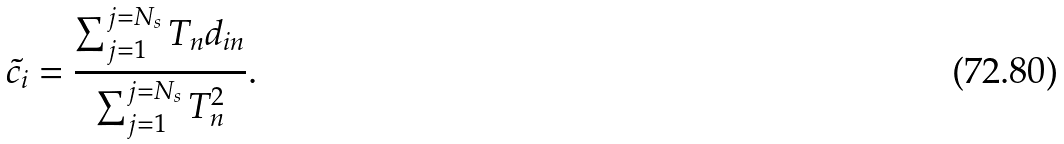<formula> <loc_0><loc_0><loc_500><loc_500>\tilde { c _ { i } } = \frac { \sum _ { j = 1 } ^ { j = N _ { s } } T _ { n } d _ { i n } } { \sum _ { j = 1 } ^ { j = N _ { s } } T _ { n } ^ { 2 } } .</formula> 